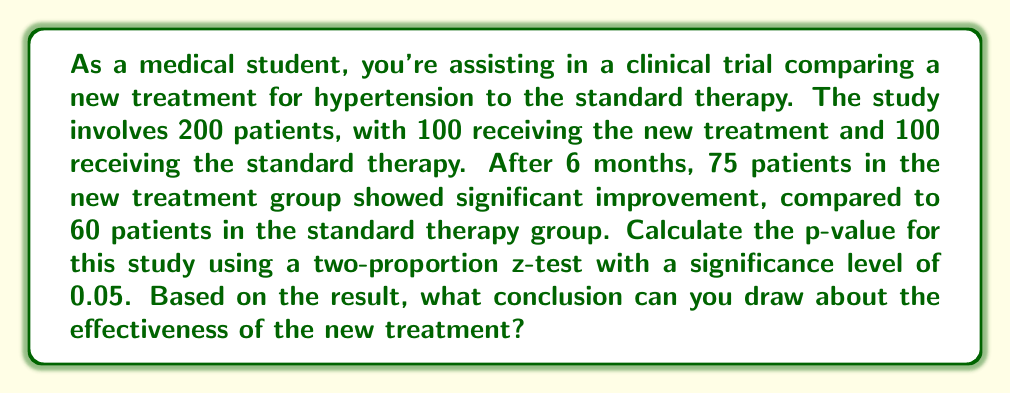Can you solve this math problem? To analyze the effectiveness of the new treatment compared to the standard therapy, we'll use a two-proportion z-test. This test is appropriate when comparing two independent proportions from large samples.

Step 1: Define the null and alternative hypotheses
$H_0: p_1 = p_2$ (The proportion of patients improving is the same for both treatments)
$H_a: p_1 \neq p_2$ (The proportion of patients improving is different between treatments)

Step 2: Calculate the pooled sample proportion
$\hat{p} = \frac{X_1 + X_2}{n_1 + n_2} = \frac{75 + 60}{100 + 100} = \frac{135}{200} = 0.675$

Step 3: Calculate the standard error
$SE = \sqrt{\hat{p}(1-\hat{p})(\frac{1}{n_1} + \frac{1}{n_2})}$
$SE = \sqrt{0.675(1-0.675)(\frac{1}{100} + \frac{1}{100})} = 0.0661$

Step 4: Calculate the z-statistic
$z = \frac{(\hat{p_1} - \hat{p_2})}{\sqrt{\hat{p}(1-\hat{p})(\frac{1}{n_1} + \frac{1}{n_2})}}$
$z = \frac{(0.75 - 0.60)}{0.0661} = 2.27$

Step 5: Calculate the p-value
For a two-tailed test, p-value $= 2 \times P(Z > |z|)$
Using a standard normal distribution table or calculator:
p-value $= 2 \times P(Z > 2.27) = 2 \times 0.0116 = 0.0232$

Step 6: Compare the p-value to the significance level
The p-value (0.0232) is less than the significance level (0.05).

Step 7: Draw a conclusion
Since the p-value is less than the significance level, we reject the null hypothesis. There is sufficient evidence to conclude that there is a statistically significant difference between the effectiveness of the new treatment and the standard therapy.
Answer: The p-value is 0.0232. Since this is less than the significance level of 0.05, we reject the null hypothesis. We can conclude that there is a statistically significant difference between the effectiveness of the new treatment and the standard therapy, with the new treatment showing a higher proportion of patients improving. 